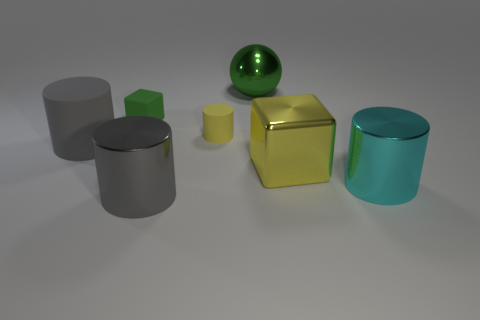Subtract all big gray metal cylinders. How many cylinders are left? 3 Subtract all gray cylinders. How many cylinders are left? 2 Subtract 2 cylinders. How many cylinders are left? 2 Add 3 matte things. How many objects exist? 10 Subtract all blocks. How many objects are left? 5 Add 4 large gray shiny cylinders. How many large gray shiny cylinders are left? 5 Add 6 small cylinders. How many small cylinders exist? 7 Subtract 0 blue blocks. How many objects are left? 7 Subtract all purple spheres. Subtract all cyan cylinders. How many spheres are left? 1 Subtract all green cylinders. How many green blocks are left? 1 